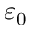<formula> <loc_0><loc_0><loc_500><loc_500>\varepsilon _ { 0 }</formula> 